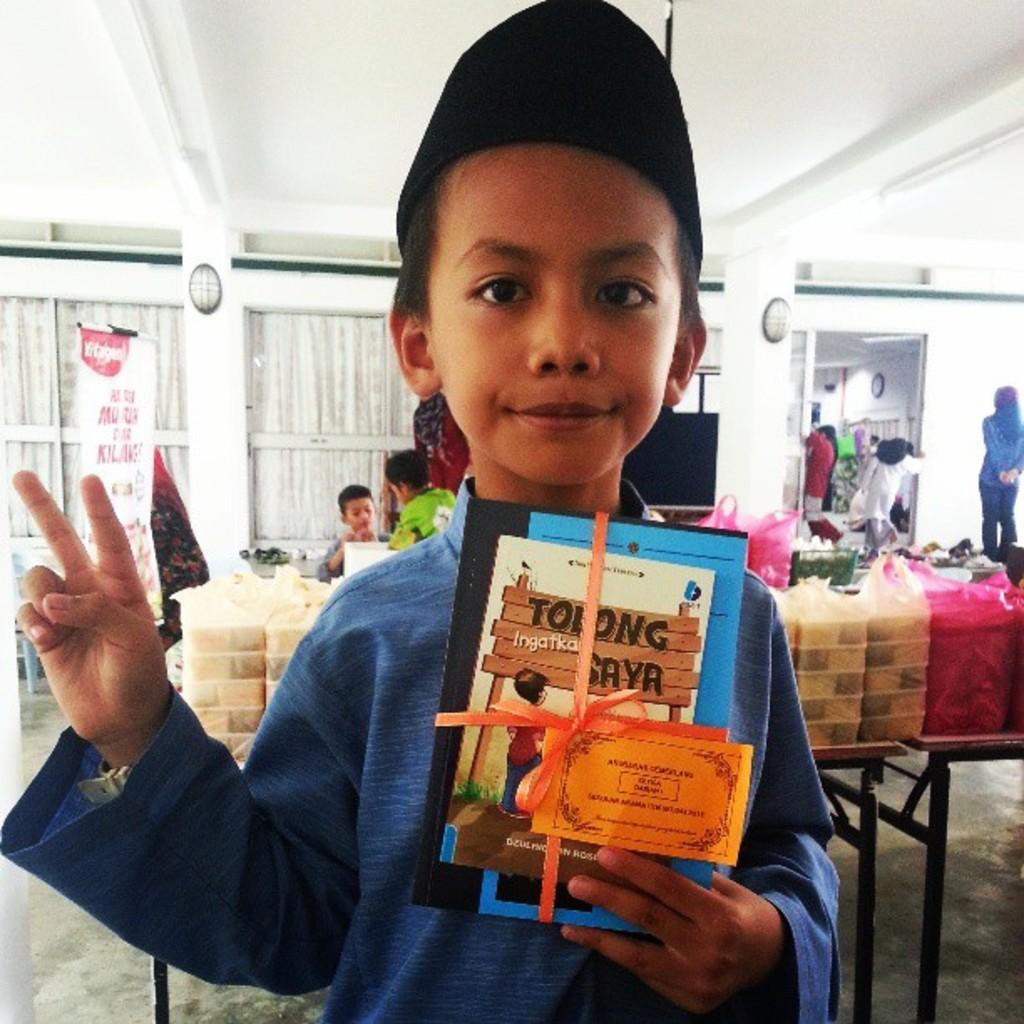Who is the main subject in the image? There is a boy in the image. What is the boy holding in his hand? The boy is holding books in his hand. What can be seen in the background of the image? There are plastic covers, windows with curtains, a banner, and people standing on the floor in the background of the image. What type of humor can be seen in the boy's expression in the image? There is no indication of humor or any specific expression on the boy's face in the image. 